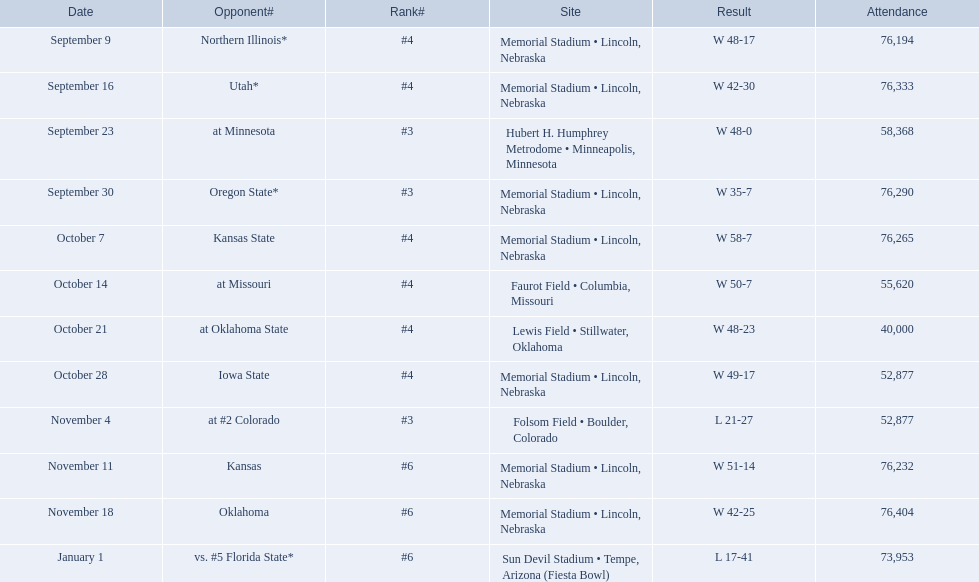In which games did the nebraska cornhuskers register fewer than 40 points against their opponents? Oregon State*, at #2 Colorado, vs. #5 Florida State*. Of these encounters, which ones had an audience exceeding 70,000? Oregon State*, vs. #5 Florida State*. Against which of these adversaries did they secure a win? Oregon State*. I'm looking to parse the entire table for insights. Could you assist me with that? {'header': ['Date', 'Opponent#', 'Rank#', 'Site', 'Result', 'Attendance'], 'rows': [['September 9', 'Northern Illinois*', '#4', 'Memorial Stadium • Lincoln, Nebraska', 'W\xa048-17', '76,194'], ['September 16', 'Utah*', '#4', 'Memorial Stadium • Lincoln, Nebraska', 'W\xa042-30', '76,333'], ['September 23', 'at\xa0Minnesota', '#3', 'Hubert H. Humphrey Metrodome • Minneapolis, Minnesota', 'W\xa048-0', '58,368'], ['September 30', 'Oregon State*', '#3', 'Memorial Stadium • Lincoln, Nebraska', 'W\xa035-7', '76,290'], ['October 7', 'Kansas State', '#4', 'Memorial Stadium • Lincoln, Nebraska', 'W\xa058-7', '76,265'], ['October 14', 'at\xa0Missouri', '#4', 'Faurot Field • Columbia, Missouri', 'W\xa050-7', '55,620'], ['October 21', 'at\xa0Oklahoma State', '#4', 'Lewis Field • Stillwater, Oklahoma', 'W\xa048-23', '40,000'], ['October 28', 'Iowa State', '#4', 'Memorial Stadium • Lincoln, Nebraska', 'W\xa049-17', '52,877'], ['November 4', 'at\xa0#2\xa0Colorado', '#3', 'Folsom Field • Boulder, Colorado', 'L\xa021-27', '52,877'], ['November 11', 'Kansas', '#6', 'Memorial Stadium • Lincoln, Nebraska', 'W\xa051-14', '76,232'], ['November 18', 'Oklahoma', '#6', 'Memorial Stadium • Lincoln, Nebraska', 'W\xa042-25', '76,404'], ['January 1', 'vs.\xa0#5\xa0Florida State*', '#6', 'Sun Devil Stadium • Tempe, Arizona (Fiesta Bowl)', 'L\xa017-41', '73,953']]} How many attendees were there in that specific match? 76,290. 